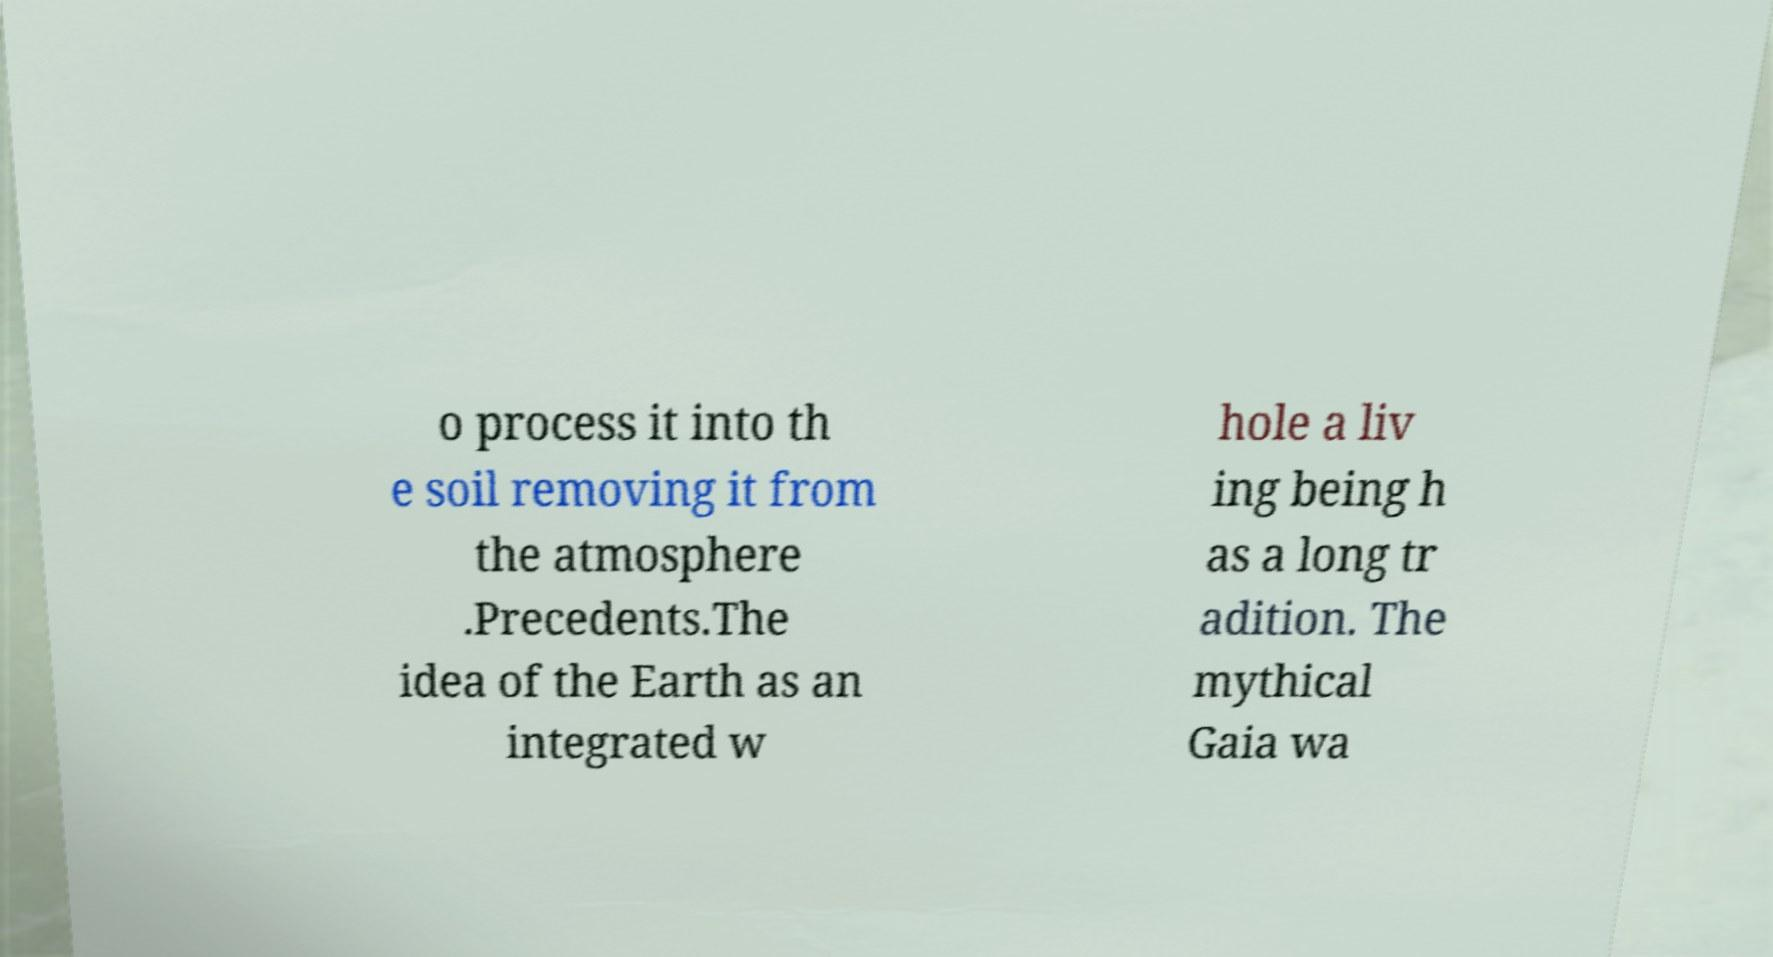Can you accurately transcribe the text from the provided image for me? o process it into th e soil removing it from the atmosphere .Precedents.The idea of the Earth as an integrated w hole a liv ing being h as a long tr adition. The mythical Gaia wa 